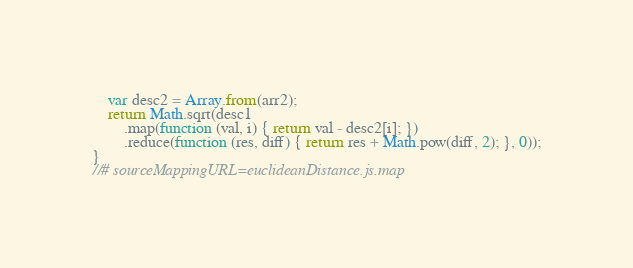Convert code to text. <code><loc_0><loc_0><loc_500><loc_500><_JavaScript_>    var desc2 = Array.from(arr2);
    return Math.sqrt(desc1
        .map(function (val, i) { return val - desc2[i]; })
        .reduce(function (res, diff) { return res + Math.pow(diff, 2); }, 0));
}
//# sourceMappingURL=euclideanDistance.js.map</code> 